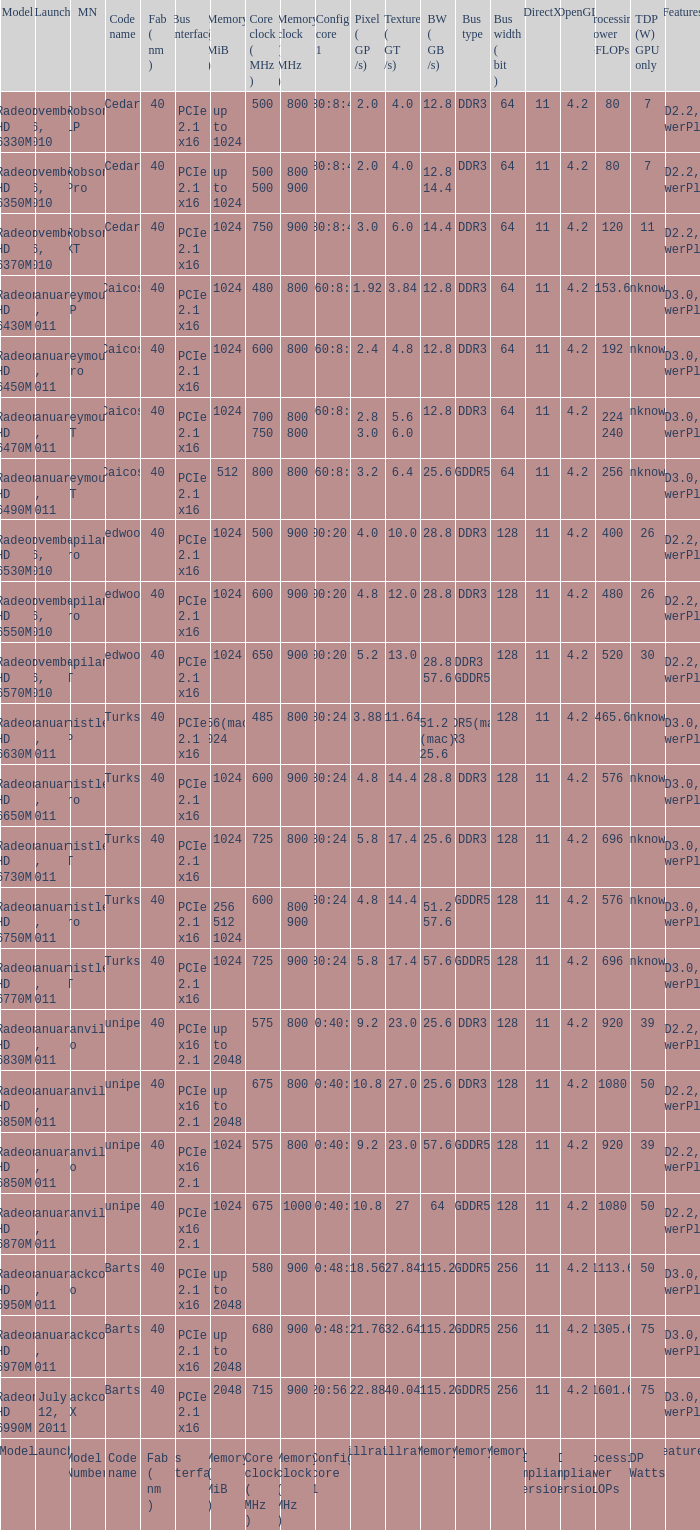What is the value for congi core 1 if the code name is Redwood and core clock(mhz) is 500? 400:20:8. 